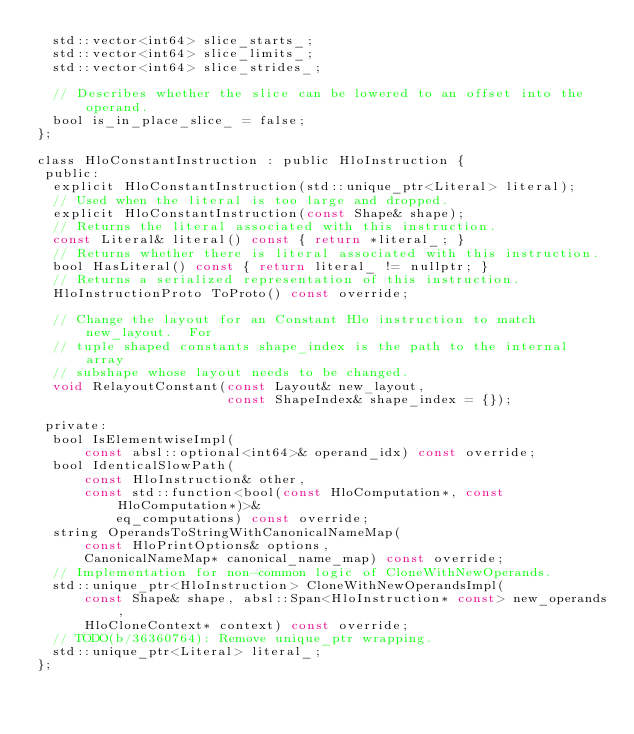Convert code to text. <code><loc_0><loc_0><loc_500><loc_500><_C_>  std::vector<int64> slice_starts_;
  std::vector<int64> slice_limits_;
  std::vector<int64> slice_strides_;

  // Describes whether the slice can be lowered to an offset into the operand.
  bool is_in_place_slice_ = false;
};

class HloConstantInstruction : public HloInstruction {
 public:
  explicit HloConstantInstruction(std::unique_ptr<Literal> literal);
  // Used when the literal is too large and dropped.
  explicit HloConstantInstruction(const Shape& shape);
  // Returns the literal associated with this instruction.
  const Literal& literal() const { return *literal_; }
  // Returns whether there is literal associated with this instruction.
  bool HasLiteral() const { return literal_ != nullptr; }
  // Returns a serialized representation of this instruction.
  HloInstructionProto ToProto() const override;

  // Change the layout for an Constant Hlo instruction to match new_layout.  For
  // tuple shaped constants shape_index is the path to the internal array
  // subshape whose layout needs to be changed.
  void RelayoutConstant(const Layout& new_layout,
                        const ShapeIndex& shape_index = {});

 private:
  bool IsElementwiseImpl(
      const absl::optional<int64>& operand_idx) const override;
  bool IdenticalSlowPath(
      const HloInstruction& other,
      const std::function<bool(const HloComputation*, const HloComputation*)>&
          eq_computations) const override;
  string OperandsToStringWithCanonicalNameMap(
      const HloPrintOptions& options,
      CanonicalNameMap* canonical_name_map) const override;
  // Implementation for non-common logic of CloneWithNewOperands.
  std::unique_ptr<HloInstruction> CloneWithNewOperandsImpl(
      const Shape& shape, absl::Span<HloInstruction* const> new_operands,
      HloCloneContext* context) const override;
  // TODO(b/36360764): Remove unique_ptr wrapping.
  std::unique_ptr<Literal> literal_;
};
</code> 